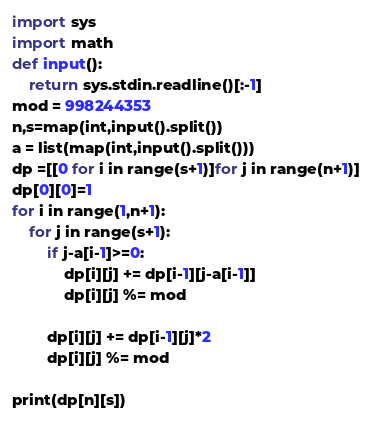<code> <loc_0><loc_0><loc_500><loc_500><_Python_>import sys
import math
def input():
    return sys.stdin.readline()[:-1]
mod = 998244353
n,s=map(int,input().split())
a = list(map(int,input().split()))
dp =[[0 for i in range(s+1)]for j in range(n+1)]
dp[0][0]=1
for i in range(1,n+1):
    for j in range(s+1):
        if j-a[i-1]>=0:
            dp[i][j] += dp[i-1][j-a[i-1]]
            dp[i][j] %= mod

        dp[i][j] += dp[i-1][j]*2
        dp[i][j] %= mod

print(dp[n][s])
</code> 